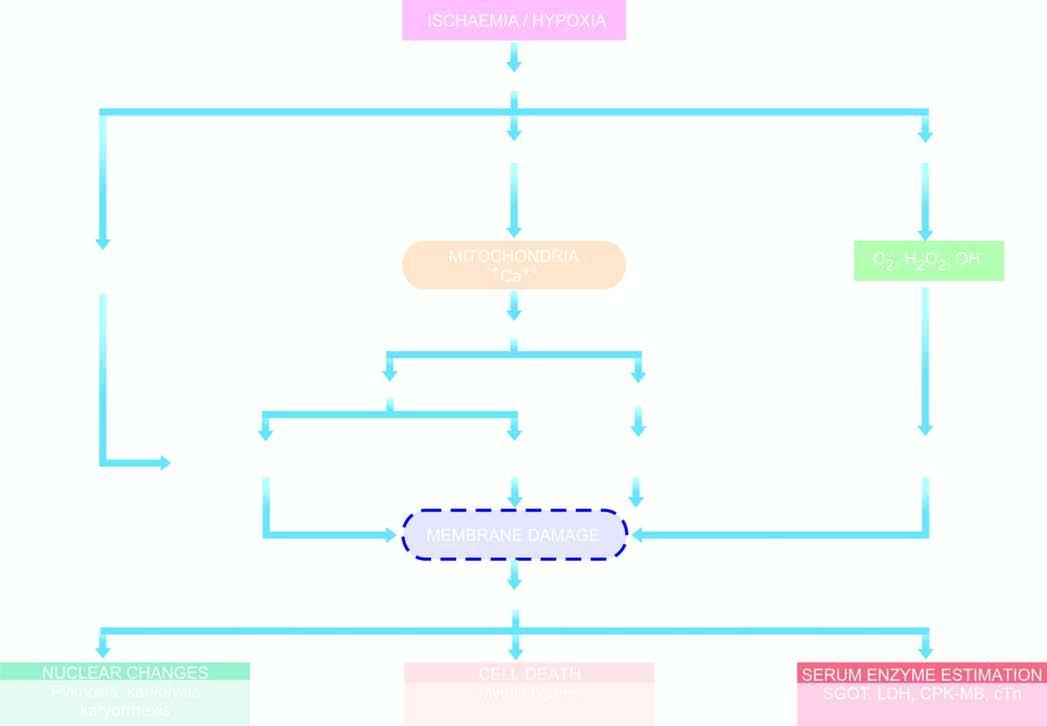what is sequence of events in the pathogenesis of reversible and irreversible cell injury cause by?
Answer the question using a single word or phrase. Hypoxia/ischaemia 